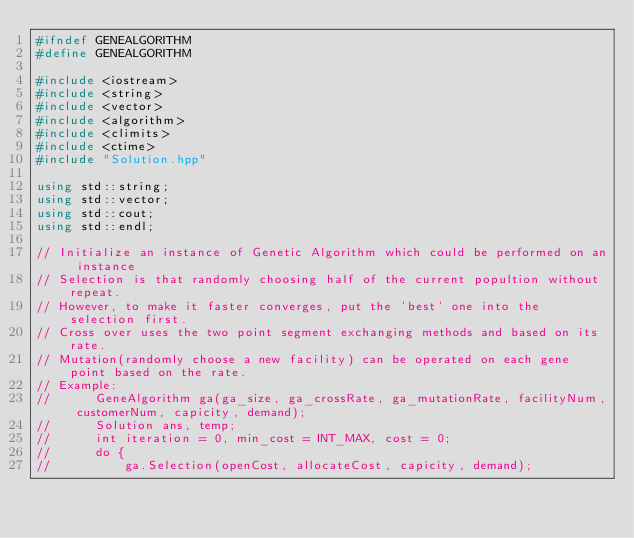Convert code to text. <code><loc_0><loc_0><loc_500><loc_500><_C++_>#ifndef GENEALGORITHM
#define GENEALGORITHM

#include <iostream>
#include <string>
#include <vector>
#include <algorithm>
#include <climits>
#include <ctime>
#include "Solution.hpp"

using std::string;
using std::vector;
using std::cout;
using std::endl;

// Initialize an instance of Genetic Algorithm which could be performed on an instance
// Selection is that randomly choosing half of the current popultion without repeat.
// However, to make it faster converges, put the 'best' one into the selection first.
// Cross over uses the two point segment exchanging methods and based on its rate.
// Mutation(randomly choose a new facility) can be operated on each gene point based on the rate.
// Example:
//      GeneAlgorithm ga(ga_size, ga_crossRate, ga_mutationRate, facilityNum, customerNum, capicity, demand);
//      Solution ans, temp;
//      int iteration = 0, min_cost = INT_MAX, cost = 0;
//      do {
//      	ga.Selection(openCost, allocateCost, capicity, demand);</code> 